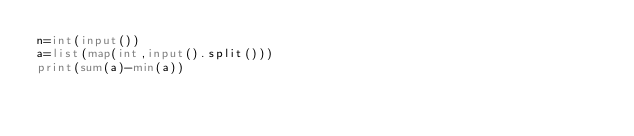<code> <loc_0><loc_0><loc_500><loc_500><_Python_>n=int(input())
a=list(map(int,input().split()))
print(sum(a)-min(a))</code> 